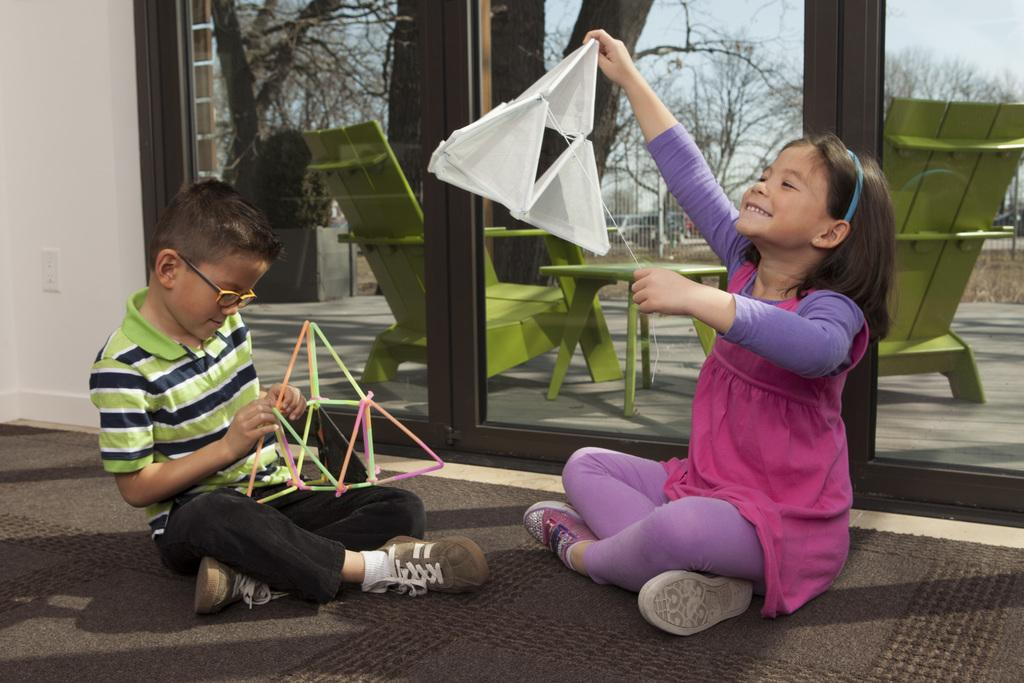How many children are present in the image? There is a boy and a girl in the image. What are the children doing in the image? The boy and girl are playing with toys. What can be seen through the glass in the image? Chairs and a table are visible through the glass. What type of vegetation is present in the image? There are trees in the image. What is the weather like in the image? The sky is cloudy in the image. What type of ray is visible in the image? There is no ray present in the image. How much profit is the boy making from playing with toys in the image? There is no indication of profit or financial gain in the image; the boy and girl are simply playing with toys. 